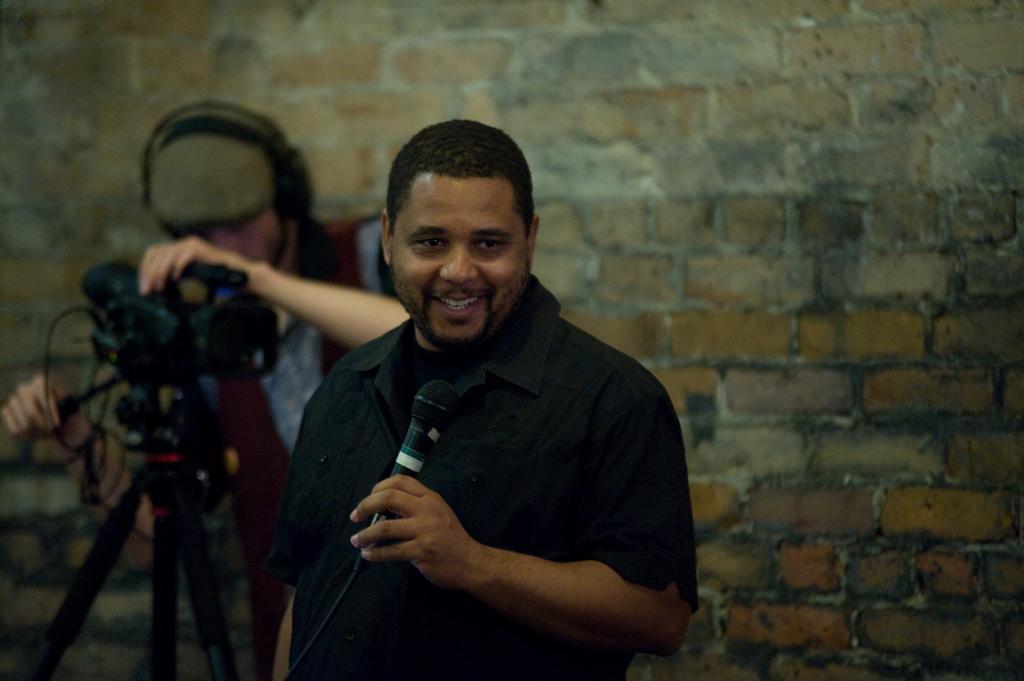How would you summarize this image in a sentence or two? in the picture we can see a person holding a micro phone another person holding a video camera with the stand,the person holding micro phone is laughing,the person holding video camera is wearing a headset. 